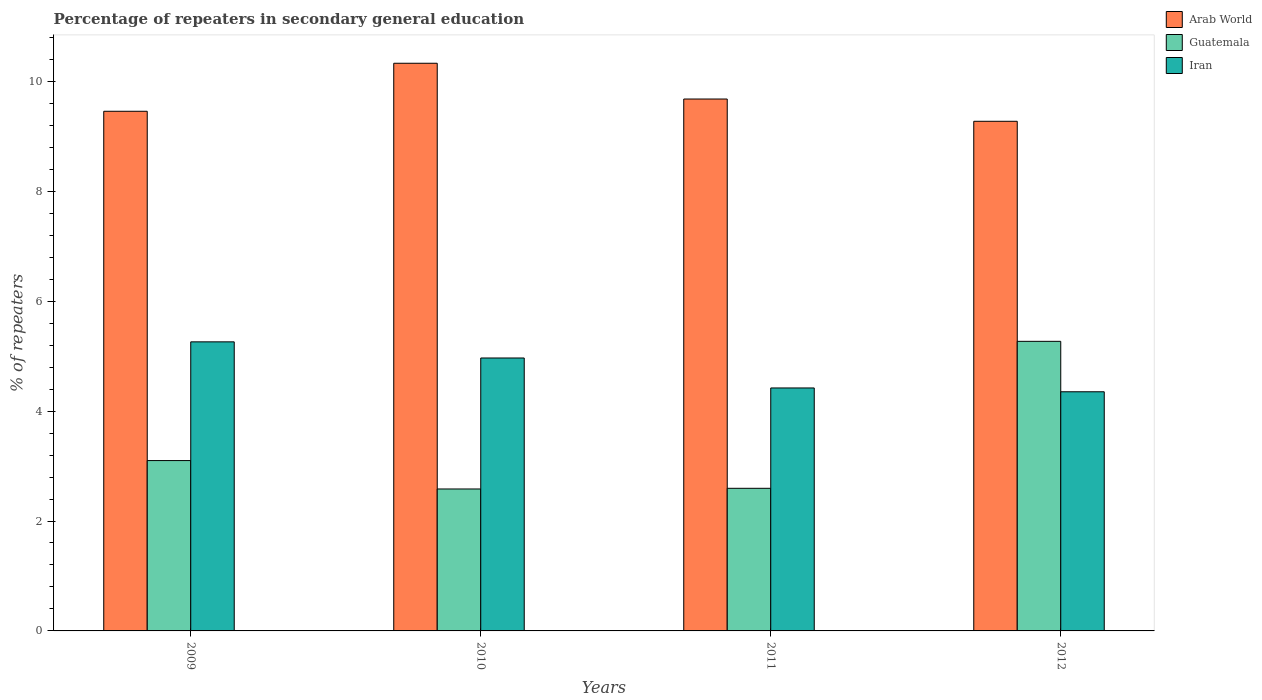Are the number of bars per tick equal to the number of legend labels?
Offer a terse response. Yes. How many bars are there on the 2nd tick from the right?
Provide a short and direct response. 3. What is the percentage of repeaters in secondary general education in Arab World in 2009?
Offer a very short reply. 9.46. Across all years, what is the maximum percentage of repeaters in secondary general education in Iran?
Your response must be concise. 5.26. Across all years, what is the minimum percentage of repeaters in secondary general education in Guatemala?
Make the answer very short. 2.58. What is the total percentage of repeaters in secondary general education in Iran in the graph?
Your answer should be very brief. 19. What is the difference between the percentage of repeaters in secondary general education in Iran in 2009 and that in 2010?
Your answer should be compact. 0.29. What is the difference between the percentage of repeaters in secondary general education in Iran in 2011 and the percentage of repeaters in secondary general education in Arab World in 2012?
Keep it short and to the point. -4.85. What is the average percentage of repeaters in secondary general education in Arab World per year?
Keep it short and to the point. 9.68. In the year 2012, what is the difference between the percentage of repeaters in secondary general education in Iran and percentage of repeaters in secondary general education in Arab World?
Offer a terse response. -4.92. In how many years, is the percentage of repeaters in secondary general education in Arab World greater than 0.8 %?
Make the answer very short. 4. What is the ratio of the percentage of repeaters in secondary general education in Guatemala in 2009 to that in 2011?
Offer a very short reply. 1.19. Is the difference between the percentage of repeaters in secondary general education in Iran in 2011 and 2012 greater than the difference between the percentage of repeaters in secondary general education in Arab World in 2011 and 2012?
Your answer should be very brief. No. What is the difference between the highest and the second highest percentage of repeaters in secondary general education in Iran?
Make the answer very short. 0.29. What is the difference between the highest and the lowest percentage of repeaters in secondary general education in Arab World?
Your response must be concise. 1.06. In how many years, is the percentage of repeaters in secondary general education in Guatemala greater than the average percentage of repeaters in secondary general education in Guatemala taken over all years?
Ensure brevity in your answer.  1. Is the sum of the percentage of repeaters in secondary general education in Arab World in 2011 and 2012 greater than the maximum percentage of repeaters in secondary general education in Iran across all years?
Provide a succinct answer. Yes. What does the 1st bar from the left in 2009 represents?
Offer a very short reply. Arab World. What does the 2nd bar from the right in 2009 represents?
Provide a short and direct response. Guatemala. Is it the case that in every year, the sum of the percentage of repeaters in secondary general education in Iran and percentage of repeaters in secondary general education in Guatemala is greater than the percentage of repeaters in secondary general education in Arab World?
Give a very brief answer. No. How many legend labels are there?
Offer a terse response. 3. How are the legend labels stacked?
Keep it short and to the point. Vertical. What is the title of the graph?
Your response must be concise. Percentage of repeaters in secondary general education. What is the label or title of the X-axis?
Ensure brevity in your answer.  Years. What is the label or title of the Y-axis?
Offer a terse response. % of repeaters. What is the % of repeaters of Arab World in 2009?
Your answer should be compact. 9.46. What is the % of repeaters of Guatemala in 2009?
Your answer should be compact. 3.1. What is the % of repeaters in Iran in 2009?
Keep it short and to the point. 5.26. What is the % of repeaters in Arab World in 2010?
Keep it short and to the point. 10.33. What is the % of repeaters of Guatemala in 2010?
Provide a succinct answer. 2.58. What is the % of repeaters of Iran in 2010?
Keep it short and to the point. 4.97. What is the % of repeaters of Arab World in 2011?
Ensure brevity in your answer.  9.68. What is the % of repeaters of Guatemala in 2011?
Give a very brief answer. 2.6. What is the % of repeaters in Iran in 2011?
Offer a very short reply. 4.42. What is the % of repeaters of Arab World in 2012?
Offer a terse response. 9.27. What is the % of repeaters in Guatemala in 2012?
Offer a very short reply. 5.27. What is the % of repeaters in Iran in 2012?
Your answer should be very brief. 4.35. Across all years, what is the maximum % of repeaters of Arab World?
Offer a terse response. 10.33. Across all years, what is the maximum % of repeaters in Guatemala?
Offer a very short reply. 5.27. Across all years, what is the maximum % of repeaters of Iran?
Your response must be concise. 5.26. Across all years, what is the minimum % of repeaters of Arab World?
Give a very brief answer. 9.27. Across all years, what is the minimum % of repeaters of Guatemala?
Your answer should be very brief. 2.58. Across all years, what is the minimum % of repeaters in Iran?
Your response must be concise. 4.35. What is the total % of repeaters of Arab World in the graph?
Keep it short and to the point. 38.74. What is the total % of repeaters of Guatemala in the graph?
Keep it short and to the point. 13.55. What is the total % of repeaters of Iran in the graph?
Offer a terse response. 19. What is the difference between the % of repeaters in Arab World in 2009 and that in 2010?
Offer a terse response. -0.87. What is the difference between the % of repeaters of Guatemala in 2009 and that in 2010?
Keep it short and to the point. 0.52. What is the difference between the % of repeaters in Iran in 2009 and that in 2010?
Your answer should be compact. 0.29. What is the difference between the % of repeaters of Arab World in 2009 and that in 2011?
Offer a very short reply. -0.22. What is the difference between the % of repeaters of Guatemala in 2009 and that in 2011?
Provide a short and direct response. 0.5. What is the difference between the % of repeaters of Iran in 2009 and that in 2011?
Your response must be concise. 0.84. What is the difference between the % of repeaters of Arab World in 2009 and that in 2012?
Your response must be concise. 0.18. What is the difference between the % of repeaters of Guatemala in 2009 and that in 2012?
Offer a terse response. -2.17. What is the difference between the % of repeaters in Iran in 2009 and that in 2012?
Keep it short and to the point. 0.91. What is the difference between the % of repeaters in Arab World in 2010 and that in 2011?
Provide a succinct answer. 0.65. What is the difference between the % of repeaters in Guatemala in 2010 and that in 2011?
Ensure brevity in your answer.  -0.01. What is the difference between the % of repeaters of Iran in 2010 and that in 2011?
Your response must be concise. 0.55. What is the difference between the % of repeaters of Arab World in 2010 and that in 2012?
Your answer should be very brief. 1.06. What is the difference between the % of repeaters of Guatemala in 2010 and that in 2012?
Offer a very short reply. -2.69. What is the difference between the % of repeaters of Iran in 2010 and that in 2012?
Your answer should be compact. 0.61. What is the difference between the % of repeaters in Arab World in 2011 and that in 2012?
Make the answer very short. 0.41. What is the difference between the % of repeaters of Guatemala in 2011 and that in 2012?
Your answer should be compact. -2.67. What is the difference between the % of repeaters of Iran in 2011 and that in 2012?
Your response must be concise. 0.07. What is the difference between the % of repeaters in Arab World in 2009 and the % of repeaters in Guatemala in 2010?
Make the answer very short. 6.87. What is the difference between the % of repeaters in Arab World in 2009 and the % of repeaters in Iran in 2010?
Make the answer very short. 4.49. What is the difference between the % of repeaters in Guatemala in 2009 and the % of repeaters in Iran in 2010?
Your response must be concise. -1.87. What is the difference between the % of repeaters of Arab World in 2009 and the % of repeaters of Guatemala in 2011?
Your answer should be very brief. 6.86. What is the difference between the % of repeaters of Arab World in 2009 and the % of repeaters of Iran in 2011?
Offer a terse response. 5.03. What is the difference between the % of repeaters in Guatemala in 2009 and the % of repeaters in Iran in 2011?
Your response must be concise. -1.32. What is the difference between the % of repeaters of Arab World in 2009 and the % of repeaters of Guatemala in 2012?
Your answer should be very brief. 4.19. What is the difference between the % of repeaters in Arab World in 2009 and the % of repeaters in Iran in 2012?
Provide a short and direct response. 5.1. What is the difference between the % of repeaters in Guatemala in 2009 and the % of repeaters in Iran in 2012?
Give a very brief answer. -1.25. What is the difference between the % of repeaters in Arab World in 2010 and the % of repeaters in Guatemala in 2011?
Your answer should be very brief. 7.73. What is the difference between the % of repeaters of Arab World in 2010 and the % of repeaters of Iran in 2011?
Offer a terse response. 5.91. What is the difference between the % of repeaters in Guatemala in 2010 and the % of repeaters in Iran in 2011?
Your answer should be very brief. -1.84. What is the difference between the % of repeaters in Arab World in 2010 and the % of repeaters in Guatemala in 2012?
Make the answer very short. 5.06. What is the difference between the % of repeaters of Arab World in 2010 and the % of repeaters of Iran in 2012?
Keep it short and to the point. 5.98. What is the difference between the % of repeaters of Guatemala in 2010 and the % of repeaters of Iran in 2012?
Ensure brevity in your answer.  -1.77. What is the difference between the % of repeaters of Arab World in 2011 and the % of repeaters of Guatemala in 2012?
Your response must be concise. 4.41. What is the difference between the % of repeaters of Arab World in 2011 and the % of repeaters of Iran in 2012?
Your answer should be very brief. 5.33. What is the difference between the % of repeaters of Guatemala in 2011 and the % of repeaters of Iran in 2012?
Offer a very short reply. -1.76. What is the average % of repeaters in Arab World per year?
Your answer should be very brief. 9.68. What is the average % of repeaters in Guatemala per year?
Your answer should be very brief. 3.39. What is the average % of repeaters of Iran per year?
Ensure brevity in your answer.  4.75. In the year 2009, what is the difference between the % of repeaters in Arab World and % of repeaters in Guatemala?
Give a very brief answer. 6.36. In the year 2009, what is the difference between the % of repeaters of Arab World and % of repeaters of Iran?
Ensure brevity in your answer.  4.2. In the year 2009, what is the difference between the % of repeaters in Guatemala and % of repeaters in Iran?
Offer a very short reply. -2.16. In the year 2010, what is the difference between the % of repeaters in Arab World and % of repeaters in Guatemala?
Ensure brevity in your answer.  7.75. In the year 2010, what is the difference between the % of repeaters of Arab World and % of repeaters of Iran?
Ensure brevity in your answer.  5.36. In the year 2010, what is the difference between the % of repeaters in Guatemala and % of repeaters in Iran?
Your response must be concise. -2.38. In the year 2011, what is the difference between the % of repeaters in Arab World and % of repeaters in Guatemala?
Your response must be concise. 7.08. In the year 2011, what is the difference between the % of repeaters in Arab World and % of repeaters in Iran?
Provide a succinct answer. 5.26. In the year 2011, what is the difference between the % of repeaters of Guatemala and % of repeaters of Iran?
Provide a succinct answer. -1.83. In the year 2012, what is the difference between the % of repeaters of Arab World and % of repeaters of Guatemala?
Ensure brevity in your answer.  4. In the year 2012, what is the difference between the % of repeaters of Arab World and % of repeaters of Iran?
Provide a short and direct response. 4.92. In the year 2012, what is the difference between the % of repeaters of Guatemala and % of repeaters of Iran?
Your answer should be compact. 0.92. What is the ratio of the % of repeaters in Arab World in 2009 to that in 2010?
Your response must be concise. 0.92. What is the ratio of the % of repeaters in Guatemala in 2009 to that in 2010?
Keep it short and to the point. 1.2. What is the ratio of the % of repeaters of Iran in 2009 to that in 2010?
Provide a short and direct response. 1.06. What is the ratio of the % of repeaters of Guatemala in 2009 to that in 2011?
Make the answer very short. 1.19. What is the ratio of the % of repeaters of Iran in 2009 to that in 2011?
Your answer should be very brief. 1.19. What is the ratio of the % of repeaters of Arab World in 2009 to that in 2012?
Provide a short and direct response. 1.02. What is the ratio of the % of repeaters in Guatemala in 2009 to that in 2012?
Ensure brevity in your answer.  0.59. What is the ratio of the % of repeaters in Iran in 2009 to that in 2012?
Ensure brevity in your answer.  1.21. What is the ratio of the % of repeaters in Arab World in 2010 to that in 2011?
Give a very brief answer. 1.07. What is the ratio of the % of repeaters of Iran in 2010 to that in 2011?
Give a very brief answer. 1.12. What is the ratio of the % of repeaters in Arab World in 2010 to that in 2012?
Give a very brief answer. 1.11. What is the ratio of the % of repeaters of Guatemala in 2010 to that in 2012?
Provide a short and direct response. 0.49. What is the ratio of the % of repeaters of Iran in 2010 to that in 2012?
Offer a terse response. 1.14. What is the ratio of the % of repeaters of Arab World in 2011 to that in 2012?
Make the answer very short. 1.04. What is the ratio of the % of repeaters of Guatemala in 2011 to that in 2012?
Give a very brief answer. 0.49. What is the difference between the highest and the second highest % of repeaters in Arab World?
Offer a very short reply. 0.65. What is the difference between the highest and the second highest % of repeaters in Guatemala?
Your response must be concise. 2.17. What is the difference between the highest and the second highest % of repeaters of Iran?
Your answer should be compact. 0.29. What is the difference between the highest and the lowest % of repeaters of Arab World?
Give a very brief answer. 1.06. What is the difference between the highest and the lowest % of repeaters in Guatemala?
Your answer should be very brief. 2.69. What is the difference between the highest and the lowest % of repeaters in Iran?
Ensure brevity in your answer.  0.91. 